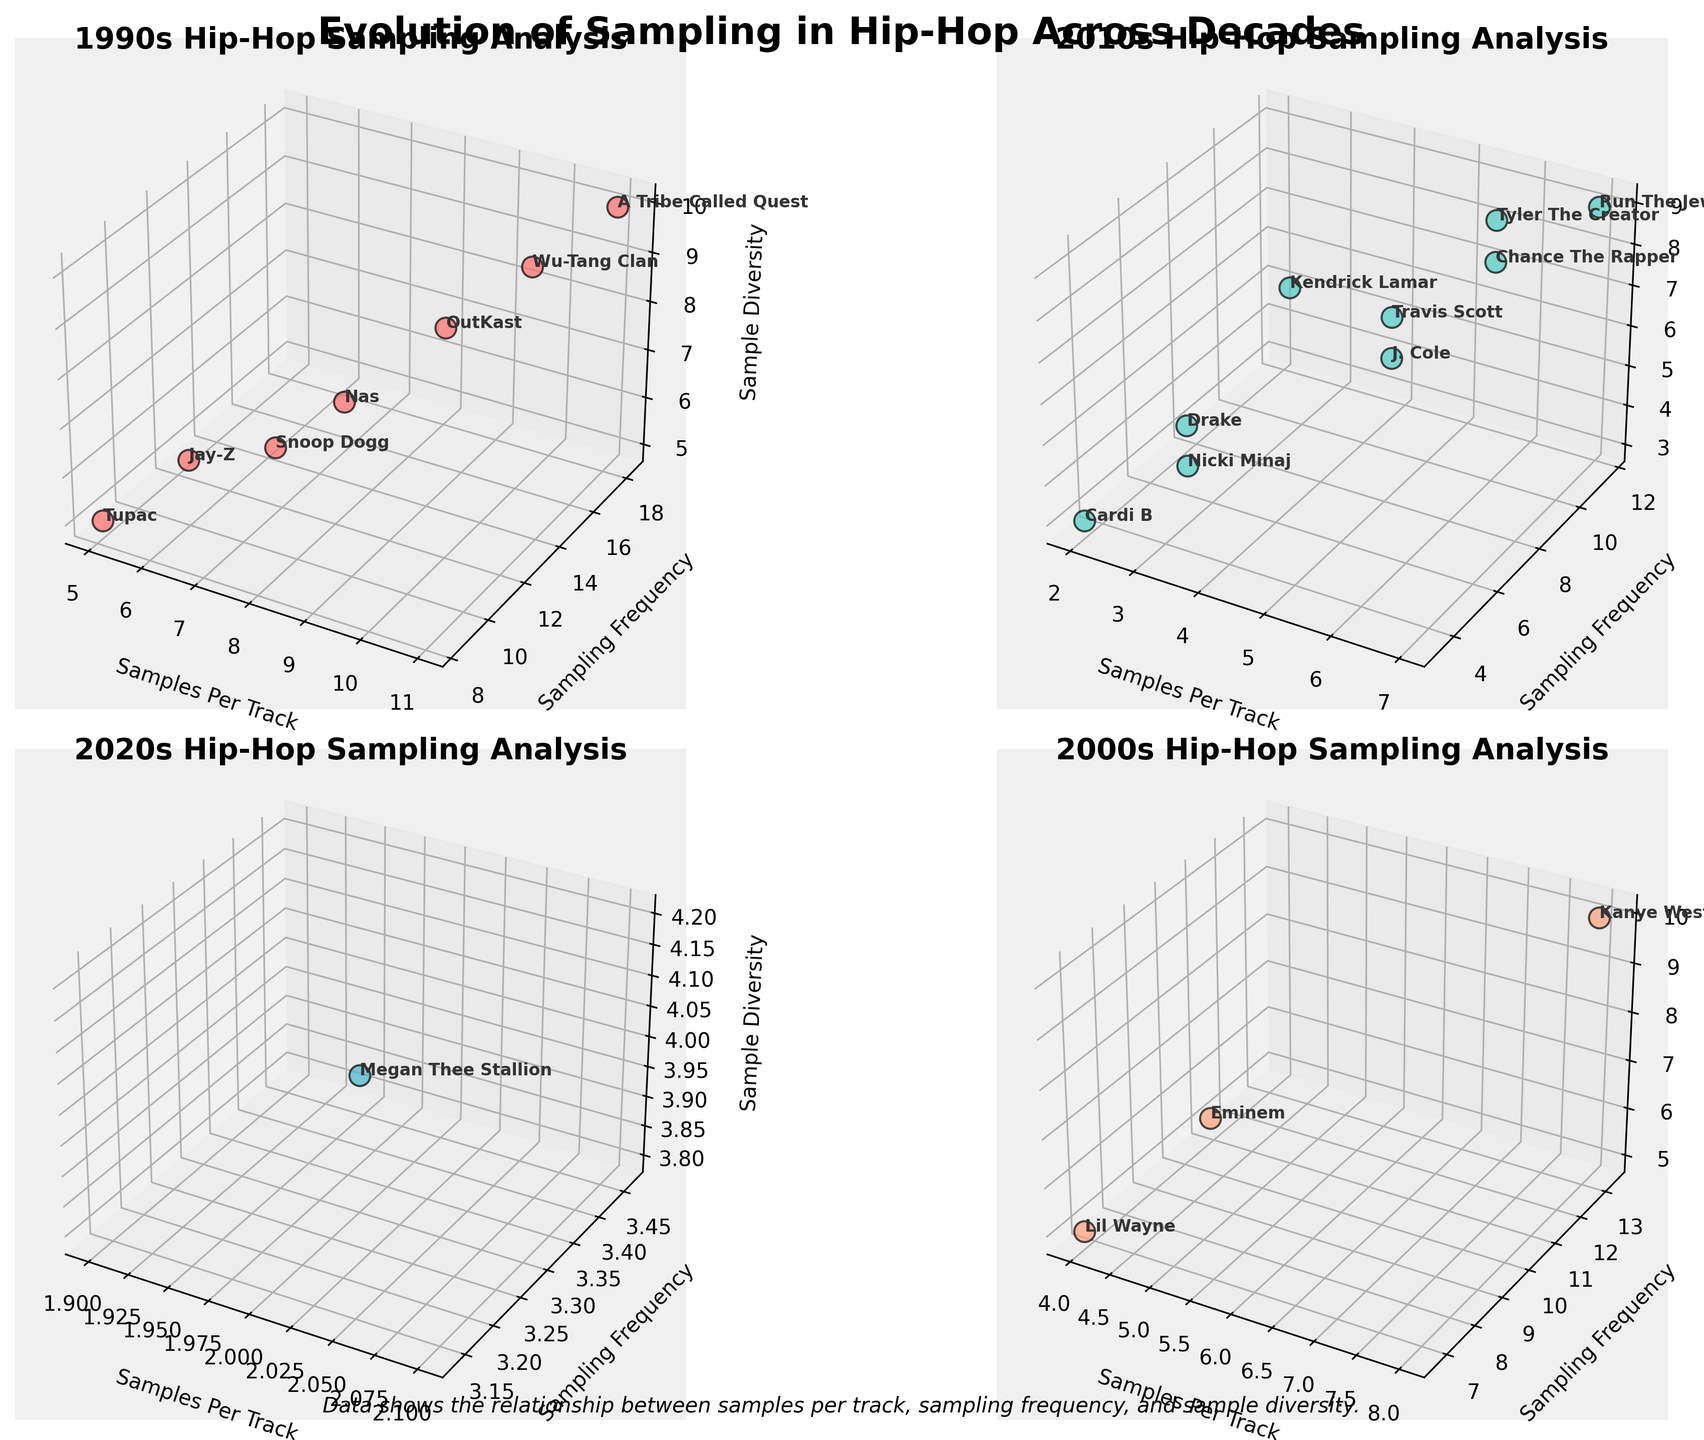Which decade is A Tribe Called Quest from? Locate A Tribe Called Quest in the 1990s subplot. The title of the subplot showing them is '1990s Hip-Hop Sampling Analysis'.
Answer: 1990s How many artists are shown in the 2010s subplot? Count the number of artists labeled in the subplot titled '2010s Hip-Hop Sampling Analysis'. There are ten artists.
Answer: 10 Which artist in the 2000s has the highest sampling frequency? Look at the height of the sampling frequency axis in the 2000s subplot. Kanye West has the highest sampling frequency.
Answer: Kanye West Compare the sample diversity between Kendrick Lamar and Snoop Dogg. Compare the z-values (Sample Diversity) of Kendrick Lamar and Snoop Dogg from the subplots of their respective decades. Kendrick's z-value is 8, and Snoop's is 6.
Answer: Kendrick Lamar has higher sample diversity Which subgenre appears in all decades plotted? Scan all four subplots to identify a subgenre that appears in the 1990s, 2000s, 2010s, and 2020s. The "Southern" subgenre is found in each.
Answer: Southern What’s the average sampling frequency for the 1990s artists? Find the y-values (sampling frequency) for all artists in the 1990s subplot, sum them up, and divide by the number of data points: (12.5 + 10.0 + 8.3 + 11.7 + 15.0 + 18.3 + 16.7) / 7 = 13.64.
Answer: 13.64 Which two artists have the same number of samples per track in the 2000s? Compare the x-values (Samples Per Track) for artists in the 2000s subplot. Eminem and Lil Wayne both have 5 samples per track.
Answer: Eminem and Lil Wayne How does the sample diversity of Tyler The Creator compare to that of A Tribe Called Quest? Compare their z-values for sample diversity: Tyler The Creator has 9, while A Tribe Called Quest has 10.
Answer: A Tribe Called Quest has higher sample diversity What is the range of samples per track for 1990s artists? Locate the minimum and maximum x-values in the 1990s subplot: the values range from 5 to 11.
Answer: 5 to 11 Who has the lowest sampling frequency in the 2020s subplot? Identify the artist with the lowest y-value in the 2020s subplot. Megan Thee Stallion is the lowest at 3.3.
Answer: Megan Thee Stallion 